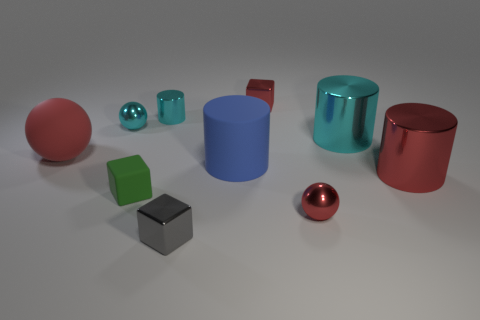There is a rubber thing that is left of the small cyan ball; is its color the same as the small shiny cube in front of the red block?
Your response must be concise. No. How many large red metallic objects are in front of the rubber object that is on the left side of the tiny shiny sphere behind the matte cylinder?
Make the answer very short. 1. How many small metal objects are in front of the tiny metal cylinder and behind the red metallic cylinder?
Offer a terse response. 1. There is a metallic sphere that is the same color as the tiny cylinder; what is its size?
Provide a succinct answer. Small. Are there an equal number of big spheres behind the tiny cyan metallic cylinder and big rubber balls that are behind the large cyan metal cylinder?
Your response must be concise. Yes. What is the color of the cube that is left of the gray shiny thing?
Your response must be concise. Green. There is a tiny ball right of the small cyan thing left of the tiny green rubber cube; what is it made of?
Keep it short and to the point. Metal. Is the number of tiny gray metal cubes to the left of the tiny cyan metal cylinder less than the number of large cyan cylinders that are in front of the blue cylinder?
Offer a very short reply. No. Is the color of the tiny rubber thing the same as the tiny cylinder?
Keep it short and to the point. No. The tiny metal object that is the same shape as the big blue thing is what color?
Give a very brief answer. Cyan. 